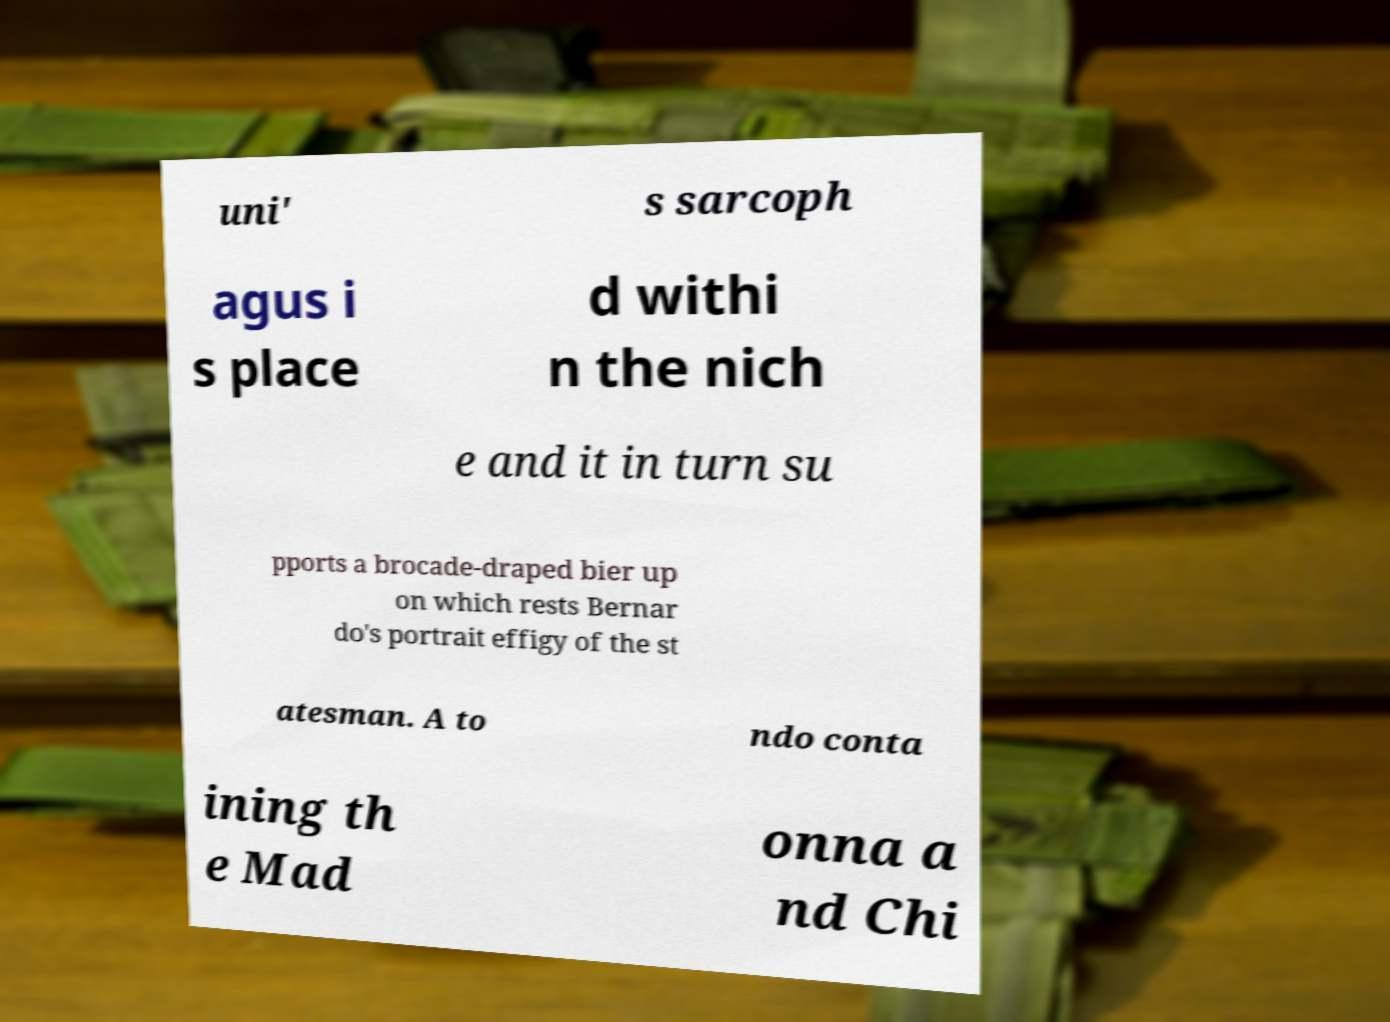Please read and relay the text visible in this image. What does it say? uni' s sarcoph agus i s place d withi n the nich e and it in turn su pports a brocade-draped bier up on which rests Bernar do's portrait effigy of the st atesman. A to ndo conta ining th e Mad onna a nd Chi 